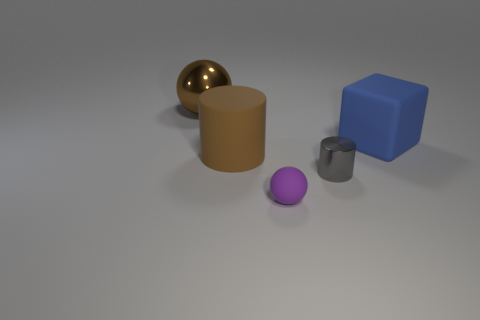There is a cylinder that is the same size as the blue block; what is its color?
Your answer should be very brief. Brown. Is there a gray thing that has the same shape as the purple matte object?
Provide a succinct answer. No. The gray shiny object is what shape?
Offer a very short reply. Cylinder. Is the number of rubber spheres that are left of the small gray cylinder greater than the number of brown balls that are left of the blue object?
Your response must be concise. No. How many other things are the same size as the metal ball?
Provide a succinct answer. 2. The thing that is on the right side of the tiny ball and on the left side of the large rubber block is made of what material?
Provide a succinct answer. Metal. What is the material of the tiny object that is the same shape as the large shiny object?
Your answer should be very brief. Rubber. There is a matte object behind the brown thing in front of the large blue matte thing; how many balls are in front of it?
Keep it short and to the point. 1. Is there any other thing that is the same color as the large matte cylinder?
Offer a very short reply. Yes. How many large brown things are behind the matte block and in front of the blue matte cube?
Provide a short and direct response. 0. 